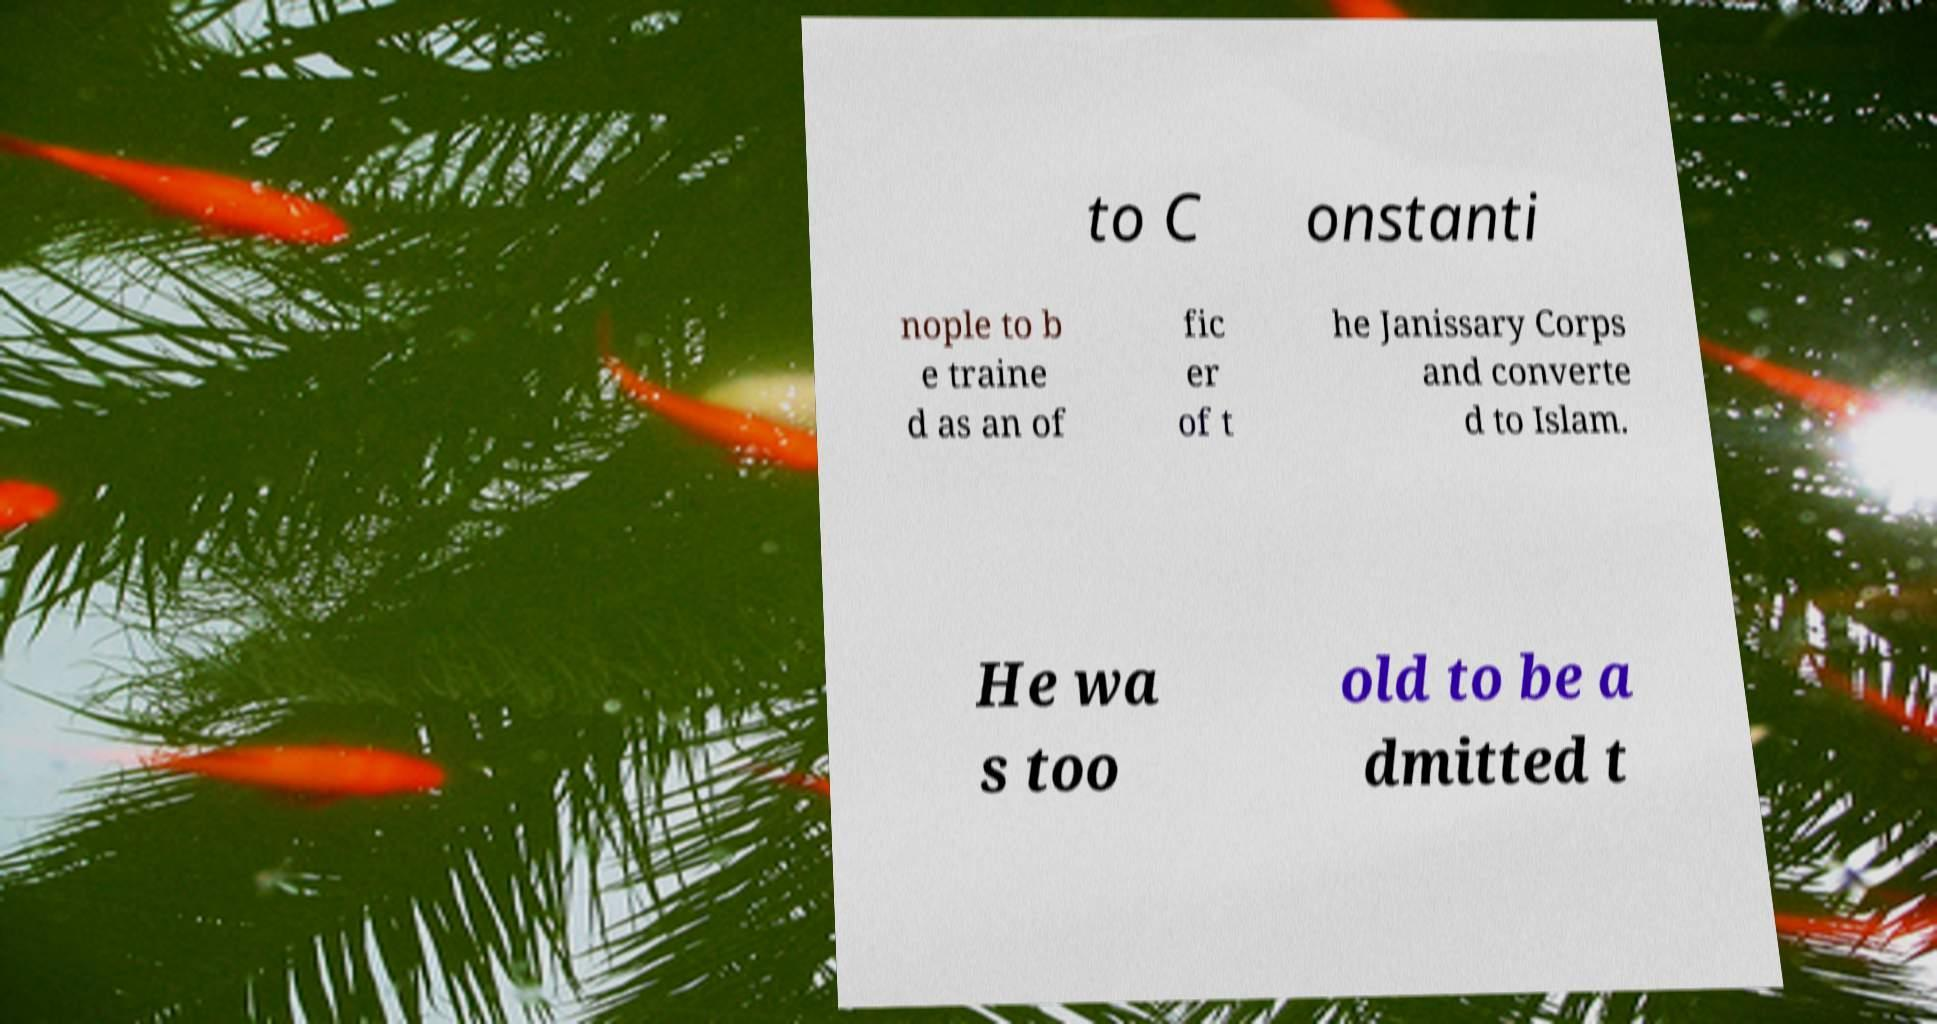For documentation purposes, I need the text within this image transcribed. Could you provide that? to C onstanti nople to b e traine d as an of fic er of t he Janissary Corps and converte d to Islam. He wa s too old to be a dmitted t 